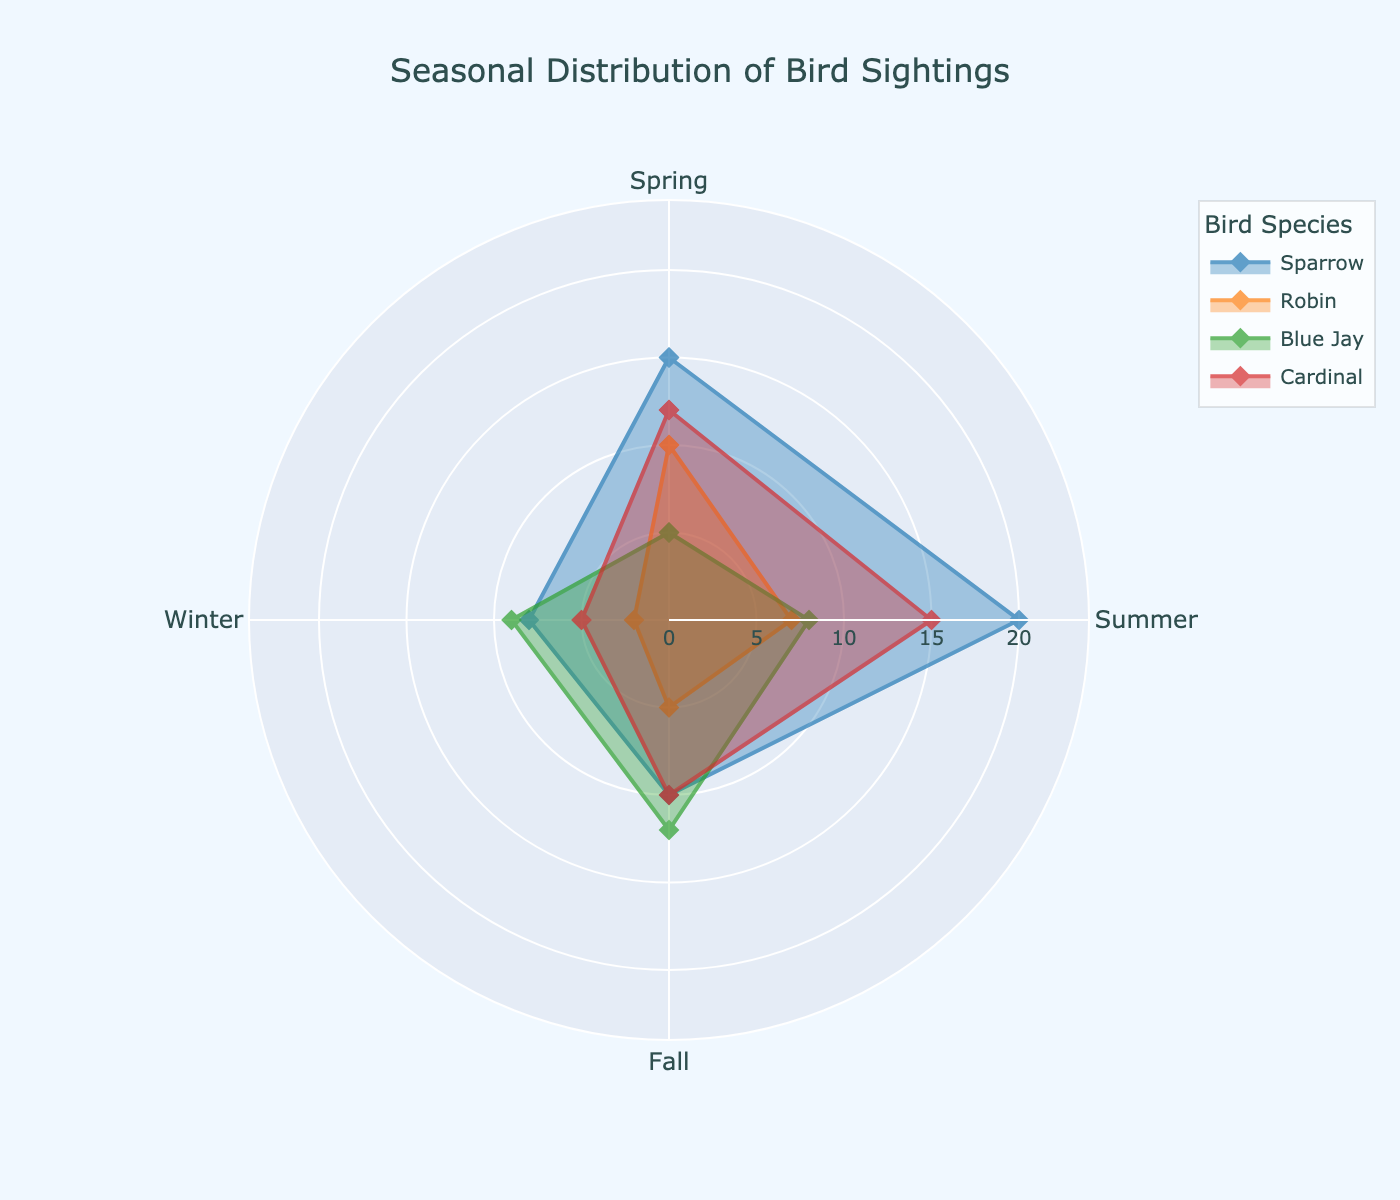What is the title of the figure? The title is displayed prominently at the top of the figure. It provides context for what the data represents.
Answer: Seasonal Distribution of Bird Sightings Which species has the highest sighting count in Summer? Observe the data points for the species' counts in the Summer section of the figure. Compare the highest count among them.
Answer: Sparrow Which season has the least Robin sightings? Locate the data points for Robin in each season and identify the season with the lowest count.
Answer: Winter What is the total number of Blue Jay sightings throughout the year? Sum the Blue Jay sightings from each season: Spring, Summer, Fall, and Winter.
Answer: 34 (5+8+12+9) Compare the Sparrow sightings in Spring and Fall. Which season has more sightings? Look at the Sparrow data points in both Spring and Fall. Compare their counts to determine which is higher.
Answer: Spring What is the average number of Cardinal sightings across all seasons? Calculate the total Cardinal sightings (Spring: 12, Summer: 15, Fall: 10, Winter: 5). Then, divide by the number of seasons. (12 + 15 + 10 + 5) / 4 = 10.5
Answer: 10.5 In which season do we see the greatest variation in bird sightings between species? Evaluate the differences in count among species for each season. Identify where the disparity is the greatest.
Answer: Summer How do the bird sighting patterns in Winter compare between Sparrows and Blue Jays? Compare the sighting counts for Winter between Sparrows (8) and Blue Jays (9). Analyze which has more or less in that season.
Answer: Blue Jays have slightly more sightings Which species has a consistent upward trend in sightings from Spring to Summer? Examine the change in sighting counts from Spring to Summer for all species. Identify the species with an increase in this period.
Answer: Sparrow How does the number of Robin sightings in Fall compare to Spring? Look at the count of Robin sightings in both Fall (5) and Spring (10). Subtract the Fall count from the Spring count.
Answer: 5 fewer in Fall 